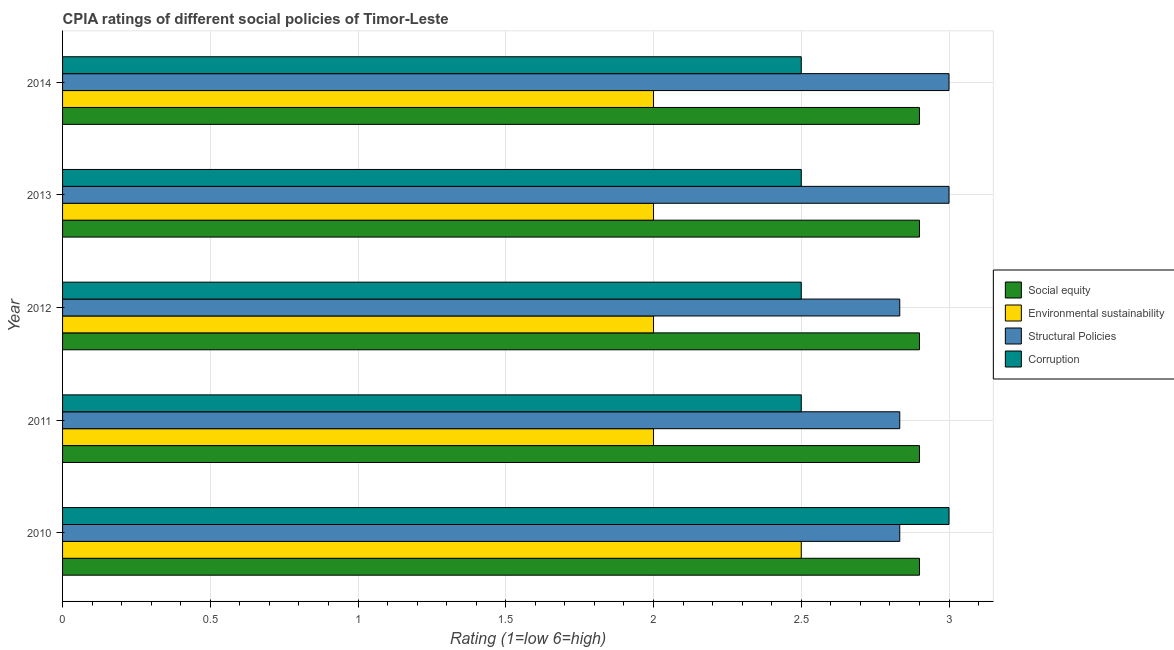How many groups of bars are there?
Ensure brevity in your answer.  5. How many bars are there on the 1st tick from the top?
Your answer should be very brief. 4. How many bars are there on the 1st tick from the bottom?
Make the answer very short. 4. What is the label of the 3rd group of bars from the top?
Your answer should be very brief. 2012. What is the cpia rating of environmental sustainability in 2014?
Provide a succinct answer. 2. Across all years, what is the minimum cpia rating of social equity?
Make the answer very short. 2.9. What is the difference between the cpia rating of environmental sustainability in 2010 and that in 2014?
Offer a very short reply. 0.5. In the year 2010, what is the difference between the cpia rating of structural policies and cpia rating of corruption?
Your answer should be compact. -0.17. What is the ratio of the cpia rating of corruption in 2010 to that in 2013?
Your answer should be very brief. 1.2. What is the difference between the highest and the second highest cpia rating of environmental sustainability?
Your answer should be compact. 0.5. What is the difference between the highest and the lowest cpia rating of structural policies?
Ensure brevity in your answer.  0.17. In how many years, is the cpia rating of corruption greater than the average cpia rating of corruption taken over all years?
Keep it short and to the point. 1. Is it the case that in every year, the sum of the cpia rating of social equity and cpia rating of structural policies is greater than the sum of cpia rating of corruption and cpia rating of environmental sustainability?
Give a very brief answer. Yes. What does the 1st bar from the top in 2012 represents?
Your response must be concise. Corruption. What does the 4th bar from the bottom in 2012 represents?
Offer a terse response. Corruption. Is it the case that in every year, the sum of the cpia rating of social equity and cpia rating of environmental sustainability is greater than the cpia rating of structural policies?
Offer a terse response. Yes. Are all the bars in the graph horizontal?
Make the answer very short. Yes. How many years are there in the graph?
Ensure brevity in your answer.  5. What is the difference between two consecutive major ticks on the X-axis?
Provide a short and direct response. 0.5. Are the values on the major ticks of X-axis written in scientific E-notation?
Keep it short and to the point. No. Does the graph contain any zero values?
Make the answer very short. No. How many legend labels are there?
Make the answer very short. 4. How are the legend labels stacked?
Provide a succinct answer. Vertical. What is the title of the graph?
Your answer should be compact. CPIA ratings of different social policies of Timor-Leste. Does "Macroeconomic management" appear as one of the legend labels in the graph?
Ensure brevity in your answer.  No. What is the Rating (1=low 6=high) in Structural Policies in 2010?
Your answer should be compact. 2.83. What is the Rating (1=low 6=high) of Social equity in 2011?
Keep it short and to the point. 2.9. What is the Rating (1=low 6=high) in Structural Policies in 2011?
Give a very brief answer. 2.83. What is the Rating (1=low 6=high) of Corruption in 2011?
Ensure brevity in your answer.  2.5. What is the Rating (1=low 6=high) of Social equity in 2012?
Provide a succinct answer. 2.9. What is the Rating (1=low 6=high) of Environmental sustainability in 2012?
Keep it short and to the point. 2. What is the Rating (1=low 6=high) of Structural Policies in 2012?
Your answer should be very brief. 2.83. What is the Rating (1=low 6=high) in Corruption in 2012?
Offer a terse response. 2.5. What is the Rating (1=low 6=high) of Social equity in 2013?
Provide a short and direct response. 2.9. What is the Rating (1=low 6=high) of Environmental sustainability in 2013?
Keep it short and to the point. 2. Across all years, what is the maximum Rating (1=low 6=high) of Environmental sustainability?
Ensure brevity in your answer.  2.5. Across all years, what is the minimum Rating (1=low 6=high) of Structural Policies?
Provide a succinct answer. 2.83. What is the total Rating (1=low 6=high) of Social equity in the graph?
Keep it short and to the point. 14.5. What is the total Rating (1=low 6=high) of Structural Policies in the graph?
Offer a terse response. 14.5. What is the total Rating (1=low 6=high) in Corruption in the graph?
Provide a short and direct response. 13. What is the difference between the Rating (1=low 6=high) of Environmental sustainability in 2010 and that in 2011?
Provide a short and direct response. 0.5. What is the difference between the Rating (1=low 6=high) of Structural Policies in 2010 and that in 2011?
Provide a succinct answer. 0. What is the difference between the Rating (1=low 6=high) in Social equity in 2010 and that in 2012?
Make the answer very short. 0. What is the difference between the Rating (1=low 6=high) in Environmental sustainability in 2010 and that in 2012?
Your answer should be compact. 0.5. What is the difference between the Rating (1=low 6=high) of Structural Policies in 2010 and that in 2012?
Your response must be concise. 0. What is the difference between the Rating (1=low 6=high) in Corruption in 2010 and that in 2012?
Your answer should be compact. 0.5. What is the difference between the Rating (1=low 6=high) of Social equity in 2010 and that in 2014?
Make the answer very short. 0. What is the difference between the Rating (1=low 6=high) of Environmental sustainability in 2010 and that in 2014?
Provide a succinct answer. 0.5. What is the difference between the Rating (1=low 6=high) of Structural Policies in 2010 and that in 2014?
Give a very brief answer. -0.17. What is the difference between the Rating (1=low 6=high) in Social equity in 2011 and that in 2013?
Provide a succinct answer. 0. What is the difference between the Rating (1=low 6=high) of Environmental sustainability in 2011 and that in 2013?
Provide a short and direct response. 0. What is the difference between the Rating (1=low 6=high) of Structural Policies in 2011 and that in 2013?
Make the answer very short. -0.17. What is the difference between the Rating (1=low 6=high) in Corruption in 2011 and that in 2013?
Provide a succinct answer. 0. What is the difference between the Rating (1=low 6=high) in Social equity in 2011 and that in 2014?
Your answer should be compact. 0. What is the difference between the Rating (1=low 6=high) in Environmental sustainability in 2011 and that in 2014?
Ensure brevity in your answer.  0. What is the difference between the Rating (1=low 6=high) in Structural Policies in 2011 and that in 2014?
Provide a short and direct response. -0.17. What is the difference between the Rating (1=low 6=high) in Corruption in 2011 and that in 2014?
Your answer should be compact. 0. What is the difference between the Rating (1=low 6=high) of Environmental sustainability in 2012 and that in 2013?
Make the answer very short. 0. What is the difference between the Rating (1=low 6=high) in Corruption in 2012 and that in 2013?
Keep it short and to the point. 0. What is the difference between the Rating (1=low 6=high) of Structural Policies in 2012 and that in 2014?
Provide a short and direct response. -0.17. What is the difference between the Rating (1=low 6=high) of Corruption in 2012 and that in 2014?
Provide a succinct answer. 0. What is the difference between the Rating (1=low 6=high) of Social equity in 2010 and the Rating (1=low 6=high) of Structural Policies in 2011?
Your answer should be compact. 0.07. What is the difference between the Rating (1=low 6=high) in Social equity in 2010 and the Rating (1=low 6=high) in Corruption in 2011?
Provide a short and direct response. 0.4. What is the difference between the Rating (1=low 6=high) of Social equity in 2010 and the Rating (1=low 6=high) of Environmental sustainability in 2012?
Your response must be concise. 0.9. What is the difference between the Rating (1=low 6=high) of Social equity in 2010 and the Rating (1=low 6=high) of Structural Policies in 2012?
Your answer should be very brief. 0.07. What is the difference between the Rating (1=low 6=high) of Social equity in 2010 and the Rating (1=low 6=high) of Corruption in 2012?
Provide a short and direct response. 0.4. What is the difference between the Rating (1=low 6=high) in Environmental sustainability in 2010 and the Rating (1=low 6=high) in Structural Policies in 2012?
Provide a succinct answer. -0.33. What is the difference between the Rating (1=low 6=high) of Environmental sustainability in 2010 and the Rating (1=low 6=high) of Corruption in 2012?
Offer a very short reply. 0. What is the difference between the Rating (1=low 6=high) in Social equity in 2010 and the Rating (1=low 6=high) in Environmental sustainability in 2013?
Your response must be concise. 0.9. What is the difference between the Rating (1=low 6=high) of Social equity in 2010 and the Rating (1=low 6=high) of Structural Policies in 2013?
Provide a short and direct response. -0.1. What is the difference between the Rating (1=low 6=high) in Social equity in 2010 and the Rating (1=low 6=high) in Corruption in 2013?
Offer a terse response. 0.4. What is the difference between the Rating (1=low 6=high) of Environmental sustainability in 2010 and the Rating (1=low 6=high) of Structural Policies in 2013?
Keep it short and to the point. -0.5. What is the difference between the Rating (1=low 6=high) of Structural Policies in 2010 and the Rating (1=low 6=high) of Corruption in 2013?
Provide a succinct answer. 0.33. What is the difference between the Rating (1=low 6=high) in Social equity in 2010 and the Rating (1=low 6=high) in Structural Policies in 2014?
Your answer should be very brief. -0.1. What is the difference between the Rating (1=low 6=high) of Environmental sustainability in 2010 and the Rating (1=low 6=high) of Corruption in 2014?
Your answer should be very brief. 0. What is the difference between the Rating (1=low 6=high) of Social equity in 2011 and the Rating (1=low 6=high) of Structural Policies in 2012?
Give a very brief answer. 0.07. What is the difference between the Rating (1=low 6=high) in Social equity in 2011 and the Rating (1=low 6=high) in Corruption in 2012?
Your response must be concise. 0.4. What is the difference between the Rating (1=low 6=high) in Environmental sustainability in 2011 and the Rating (1=low 6=high) in Corruption in 2012?
Keep it short and to the point. -0.5. What is the difference between the Rating (1=low 6=high) of Structural Policies in 2011 and the Rating (1=low 6=high) of Corruption in 2012?
Ensure brevity in your answer.  0.33. What is the difference between the Rating (1=low 6=high) in Environmental sustainability in 2011 and the Rating (1=low 6=high) in Structural Policies in 2013?
Your answer should be very brief. -1. What is the difference between the Rating (1=low 6=high) of Environmental sustainability in 2011 and the Rating (1=low 6=high) of Corruption in 2013?
Make the answer very short. -0.5. What is the difference between the Rating (1=low 6=high) in Social equity in 2011 and the Rating (1=low 6=high) in Environmental sustainability in 2014?
Your answer should be compact. 0.9. What is the difference between the Rating (1=low 6=high) of Environmental sustainability in 2011 and the Rating (1=low 6=high) of Corruption in 2014?
Offer a terse response. -0.5. What is the difference between the Rating (1=low 6=high) in Structural Policies in 2011 and the Rating (1=low 6=high) in Corruption in 2014?
Keep it short and to the point. 0.33. What is the difference between the Rating (1=low 6=high) of Social equity in 2012 and the Rating (1=low 6=high) of Environmental sustainability in 2013?
Your response must be concise. 0.9. What is the difference between the Rating (1=low 6=high) of Environmental sustainability in 2012 and the Rating (1=low 6=high) of Corruption in 2013?
Make the answer very short. -0.5. What is the difference between the Rating (1=low 6=high) in Structural Policies in 2012 and the Rating (1=low 6=high) in Corruption in 2013?
Your answer should be very brief. 0.33. What is the difference between the Rating (1=low 6=high) of Social equity in 2012 and the Rating (1=low 6=high) of Corruption in 2014?
Your answer should be compact. 0.4. What is the difference between the Rating (1=low 6=high) of Environmental sustainability in 2012 and the Rating (1=low 6=high) of Corruption in 2014?
Keep it short and to the point. -0.5. What is the difference between the Rating (1=low 6=high) of Structural Policies in 2012 and the Rating (1=low 6=high) of Corruption in 2014?
Provide a succinct answer. 0.33. What is the difference between the Rating (1=low 6=high) in Social equity in 2013 and the Rating (1=low 6=high) in Environmental sustainability in 2014?
Give a very brief answer. 0.9. What is the difference between the Rating (1=low 6=high) in Social equity in 2013 and the Rating (1=low 6=high) in Corruption in 2014?
Provide a short and direct response. 0.4. What is the difference between the Rating (1=low 6=high) of Environmental sustainability in 2013 and the Rating (1=low 6=high) of Structural Policies in 2014?
Provide a succinct answer. -1. What is the difference between the Rating (1=low 6=high) of Environmental sustainability in 2013 and the Rating (1=low 6=high) of Corruption in 2014?
Offer a terse response. -0.5. In the year 2010, what is the difference between the Rating (1=low 6=high) in Social equity and Rating (1=low 6=high) in Structural Policies?
Offer a very short reply. 0.07. In the year 2010, what is the difference between the Rating (1=low 6=high) of Environmental sustainability and Rating (1=low 6=high) of Structural Policies?
Offer a terse response. -0.33. In the year 2010, what is the difference between the Rating (1=low 6=high) of Environmental sustainability and Rating (1=low 6=high) of Corruption?
Your answer should be very brief. -0.5. In the year 2011, what is the difference between the Rating (1=low 6=high) in Social equity and Rating (1=low 6=high) in Environmental sustainability?
Provide a succinct answer. 0.9. In the year 2011, what is the difference between the Rating (1=low 6=high) in Social equity and Rating (1=low 6=high) in Structural Policies?
Your response must be concise. 0.07. In the year 2011, what is the difference between the Rating (1=low 6=high) in Structural Policies and Rating (1=low 6=high) in Corruption?
Offer a very short reply. 0.33. In the year 2012, what is the difference between the Rating (1=low 6=high) in Social equity and Rating (1=low 6=high) in Structural Policies?
Provide a succinct answer. 0.07. In the year 2013, what is the difference between the Rating (1=low 6=high) in Social equity and Rating (1=low 6=high) in Structural Policies?
Ensure brevity in your answer.  -0.1. In the year 2014, what is the difference between the Rating (1=low 6=high) of Social equity and Rating (1=low 6=high) of Structural Policies?
Offer a terse response. -0.1. In the year 2014, what is the difference between the Rating (1=low 6=high) in Environmental sustainability and Rating (1=low 6=high) in Structural Policies?
Keep it short and to the point. -1. In the year 2014, what is the difference between the Rating (1=low 6=high) of Structural Policies and Rating (1=low 6=high) of Corruption?
Provide a short and direct response. 0.5. What is the ratio of the Rating (1=low 6=high) of Environmental sustainability in 2010 to that in 2011?
Provide a succinct answer. 1.25. What is the ratio of the Rating (1=low 6=high) of Structural Policies in 2010 to that in 2011?
Your answer should be very brief. 1. What is the ratio of the Rating (1=low 6=high) in Environmental sustainability in 2010 to that in 2012?
Make the answer very short. 1.25. What is the ratio of the Rating (1=low 6=high) of Structural Policies in 2010 to that in 2012?
Give a very brief answer. 1. What is the ratio of the Rating (1=low 6=high) in Corruption in 2010 to that in 2012?
Offer a very short reply. 1.2. What is the ratio of the Rating (1=low 6=high) in Social equity in 2010 to that in 2013?
Your answer should be compact. 1. What is the ratio of the Rating (1=low 6=high) of Environmental sustainability in 2010 to that in 2013?
Keep it short and to the point. 1.25. What is the ratio of the Rating (1=low 6=high) in Structural Policies in 2010 to that in 2013?
Offer a terse response. 0.94. What is the ratio of the Rating (1=low 6=high) of Corruption in 2010 to that in 2013?
Offer a terse response. 1.2. What is the ratio of the Rating (1=low 6=high) of Structural Policies in 2010 to that in 2014?
Give a very brief answer. 0.94. What is the ratio of the Rating (1=low 6=high) in Corruption in 2010 to that in 2014?
Make the answer very short. 1.2. What is the ratio of the Rating (1=low 6=high) of Social equity in 2011 to that in 2012?
Offer a very short reply. 1. What is the ratio of the Rating (1=low 6=high) in Environmental sustainability in 2011 to that in 2012?
Offer a very short reply. 1. What is the ratio of the Rating (1=low 6=high) of Structural Policies in 2011 to that in 2012?
Ensure brevity in your answer.  1. What is the ratio of the Rating (1=low 6=high) of Corruption in 2011 to that in 2012?
Provide a succinct answer. 1. What is the ratio of the Rating (1=low 6=high) of Structural Policies in 2011 to that in 2013?
Keep it short and to the point. 0.94. What is the ratio of the Rating (1=low 6=high) in Corruption in 2011 to that in 2013?
Your response must be concise. 1. What is the ratio of the Rating (1=low 6=high) of Environmental sustainability in 2011 to that in 2014?
Provide a succinct answer. 1. What is the ratio of the Rating (1=low 6=high) in Structural Policies in 2012 to that in 2013?
Provide a succinct answer. 0.94. What is the ratio of the Rating (1=low 6=high) of Social equity in 2012 to that in 2014?
Your answer should be compact. 1. What is the ratio of the Rating (1=low 6=high) in Environmental sustainability in 2012 to that in 2014?
Your answer should be compact. 1. What is the ratio of the Rating (1=low 6=high) of Structural Policies in 2012 to that in 2014?
Your response must be concise. 0.94. What is the ratio of the Rating (1=low 6=high) of Corruption in 2012 to that in 2014?
Your response must be concise. 1. What is the ratio of the Rating (1=low 6=high) of Environmental sustainability in 2013 to that in 2014?
Ensure brevity in your answer.  1. What is the ratio of the Rating (1=low 6=high) of Structural Policies in 2013 to that in 2014?
Your answer should be very brief. 1. What is the ratio of the Rating (1=low 6=high) in Corruption in 2013 to that in 2014?
Offer a terse response. 1. What is the difference between the highest and the second highest Rating (1=low 6=high) of Environmental sustainability?
Give a very brief answer. 0.5. What is the difference between the highest and the second highest Rating (1=low 6=high) of Structural Policies?
Give a very brief answer. 0. What is the difference between the highest and the lowest Rating (1=low 6=high) of Structural Policies?
Provide a short and direct response. 0.17. What is the difference between the highest and the lowest Rating (1=low 6=high) of Corruption?
Give a very brief answer. 0.5. 